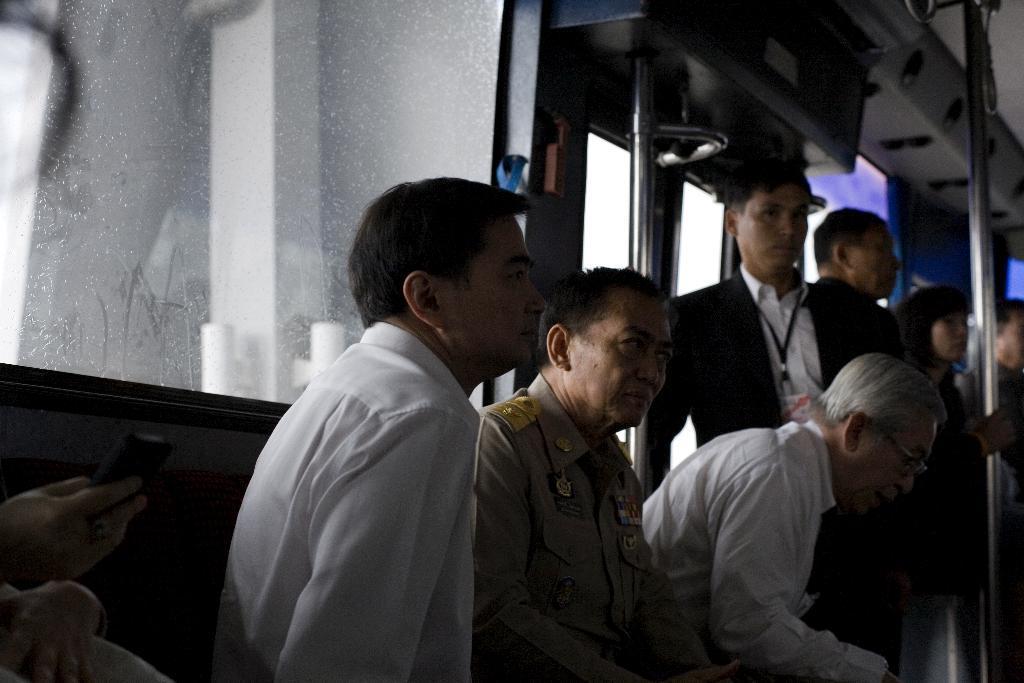Can you describe this image briefly? This image is taken inside a train. In the center of the image there is a person sitting he is wearing a white color shirt. Beside him there is another person sitting he is wearing uniform. At the left side of the image there is a hand of the person holding phone. At the right side of the image there are people standing. At the background of the image there is glass. 